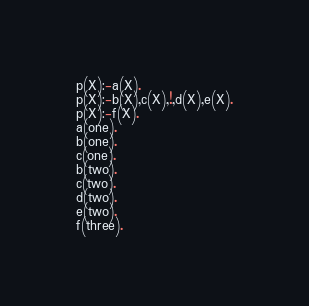<code> <loc_0><loc_0><loc_500><loc_500><_Perl_>p(X):-a(X).
p(X):-b(X),c(X),!,d(X),e(X).
p(X):-f(X).
a(one).
b(one).
c(one).
b(two).
c(two).
d(two).
e(two).
f(three).</code> 